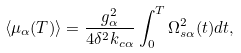<formula> <loc_0><loc_0><loc_500><loc_500>\langle \mu _ { \alpha } ( T ) \rangle = \frac { g _ { \alpha } ^ { 2 } } { 4 \delta ^ { 2 } k _ { c \alpha } } \int _ { 0 } ^ { T } \Omega _ { s \alpha } ^ { 2 } ( t ) d t ,</formula> 